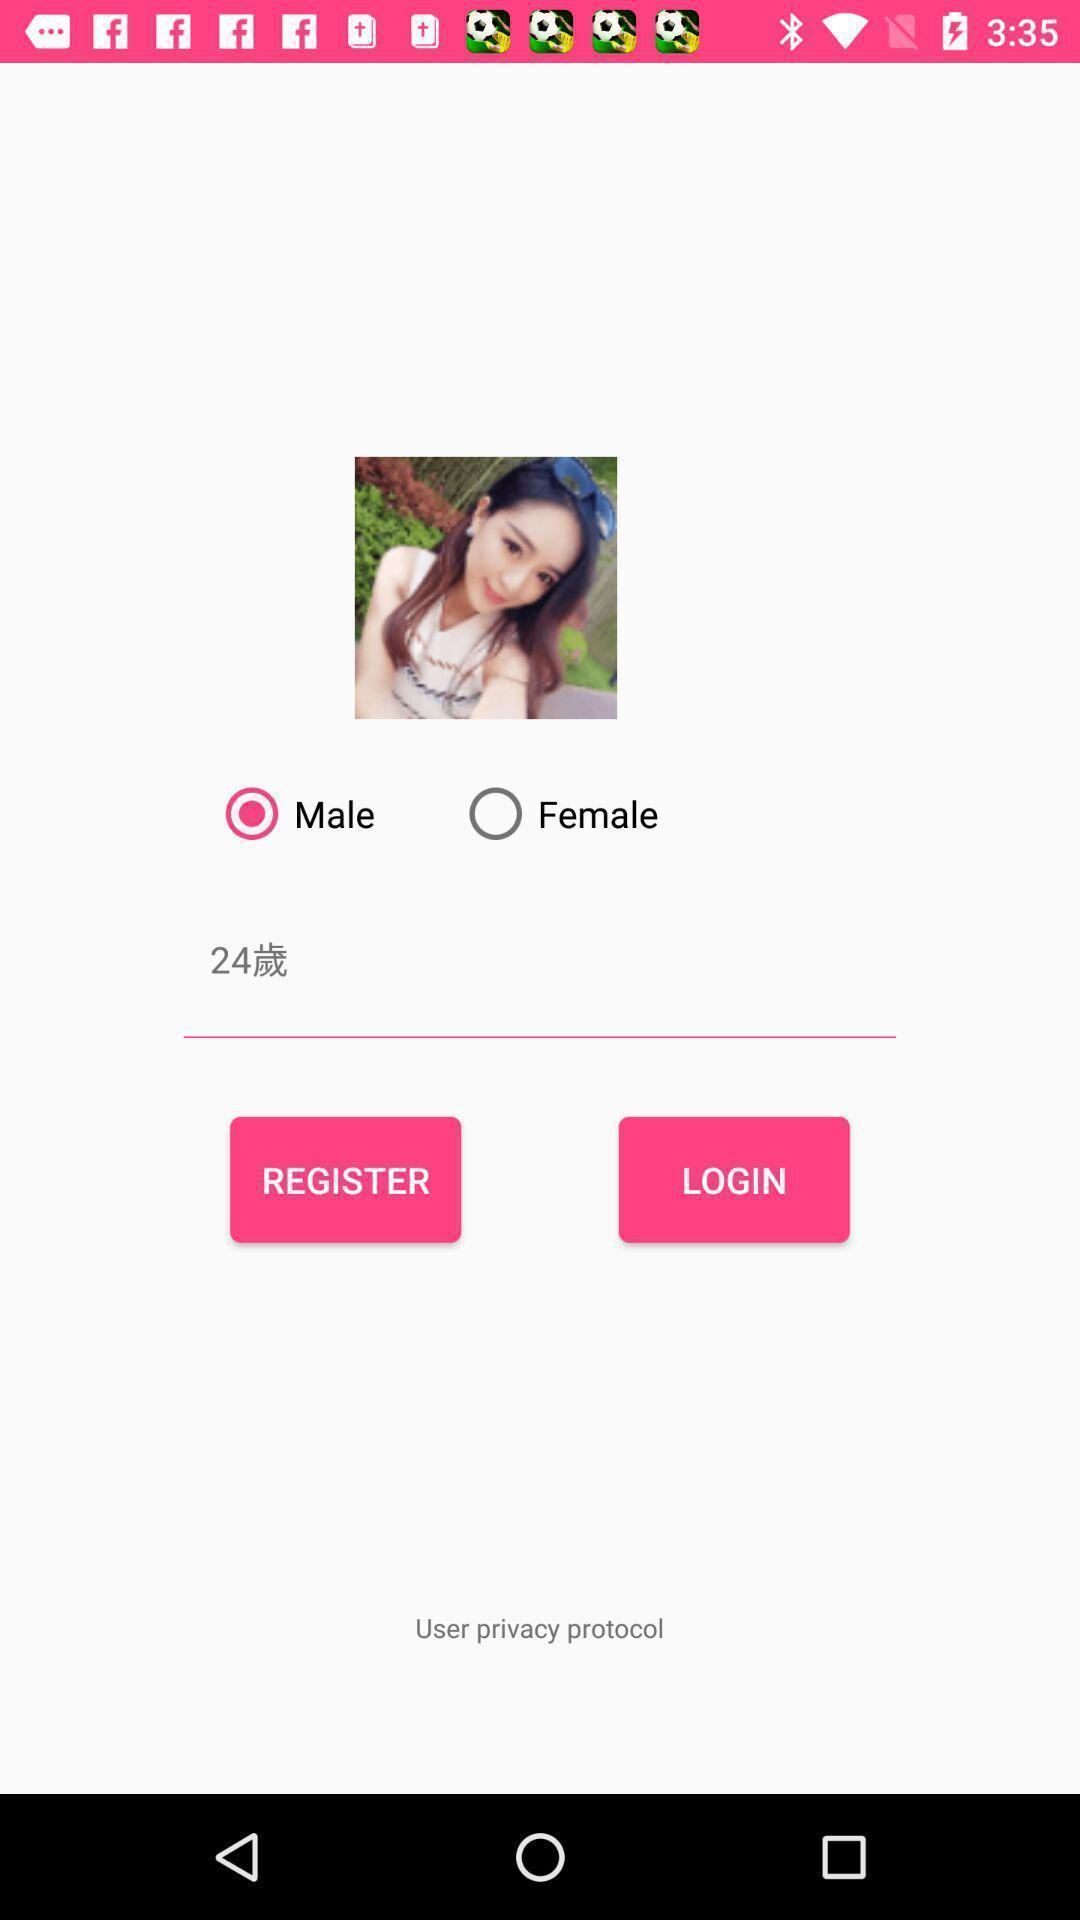Describe the content in this image. Welcome to the page of registration. 